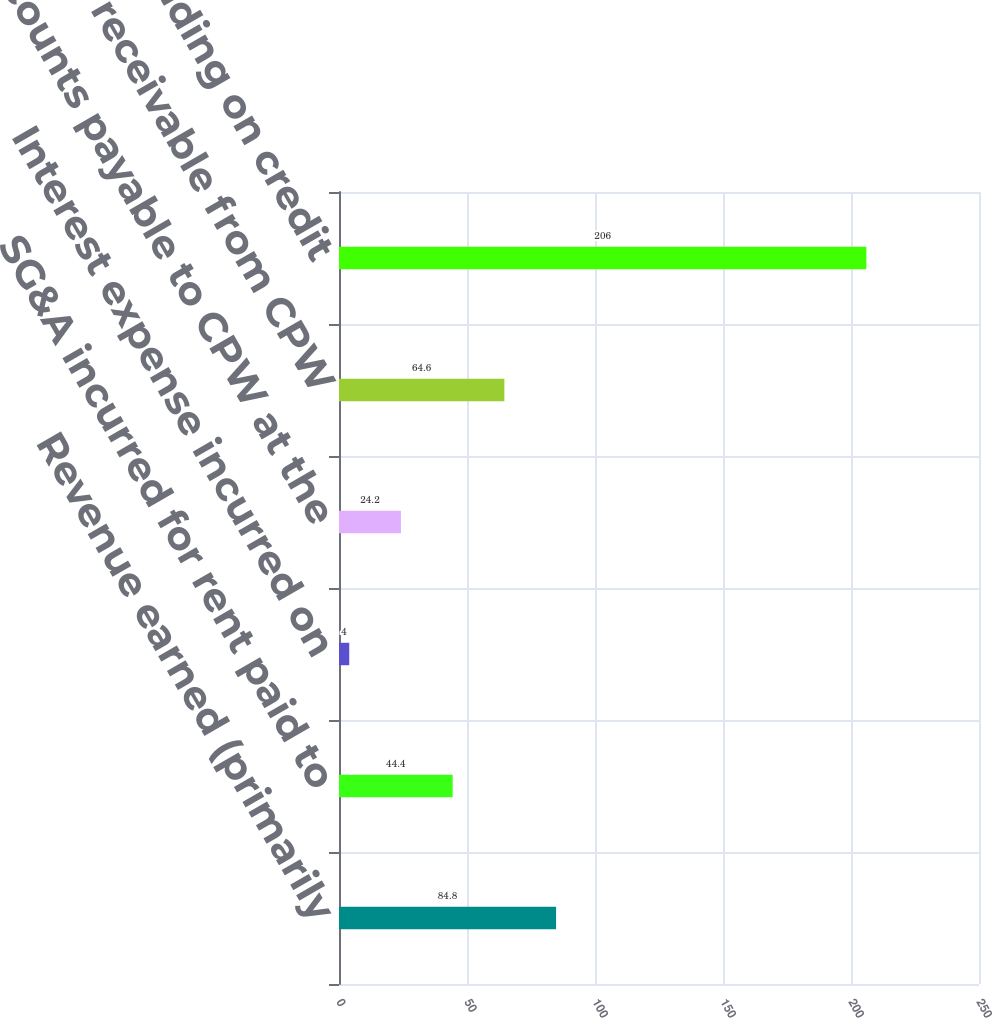Convert chart. <chart><loc_0><loc_0><loc_500><loc_500><bar_chart><fcel>Revenue earned (primarily<fcel>SG&A incurred for rent paid to<fcel>Interest expense incurred on<fcel>Accounts payable to CPW at the<fcel>Accounts receivable from CPW<fcel>Balance outstanding on credit<nl><fcel>84.8<fcel>44.4<fcel>4<fcel>24.2<fcel>64.6<fcel>206<nl></chart> 